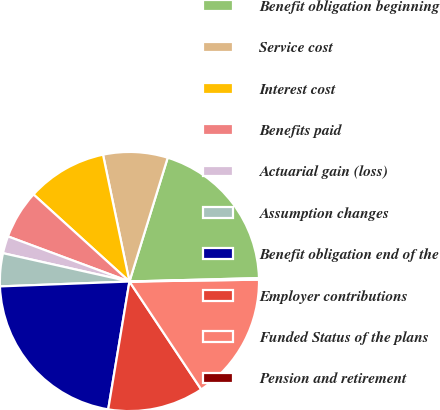Convert chart. <chart><loc_0><loc_0><loc_500><loc_500><pie_chart><fcel>Benefit obligation beginning<fcel>Service cost<fcel>Interest cost<fcel>Benefits paid<fcel>Actuarial gain (loss)<fcel>Assumption changes<fcel>Benefit obligation end of the<fcel>Employer contributions<fcel>Funded Status of the plans<fcel>Pension and retirement<nl><fcel>19.81%<fcel>8.04%<fcel>10.0%<fcel>6.07%<fcel>2.15%<fcel>4.11%<fcel>21.78%<fcel>11.96%<fcel>15.89%<fcel>0.19%<nl></chart> 